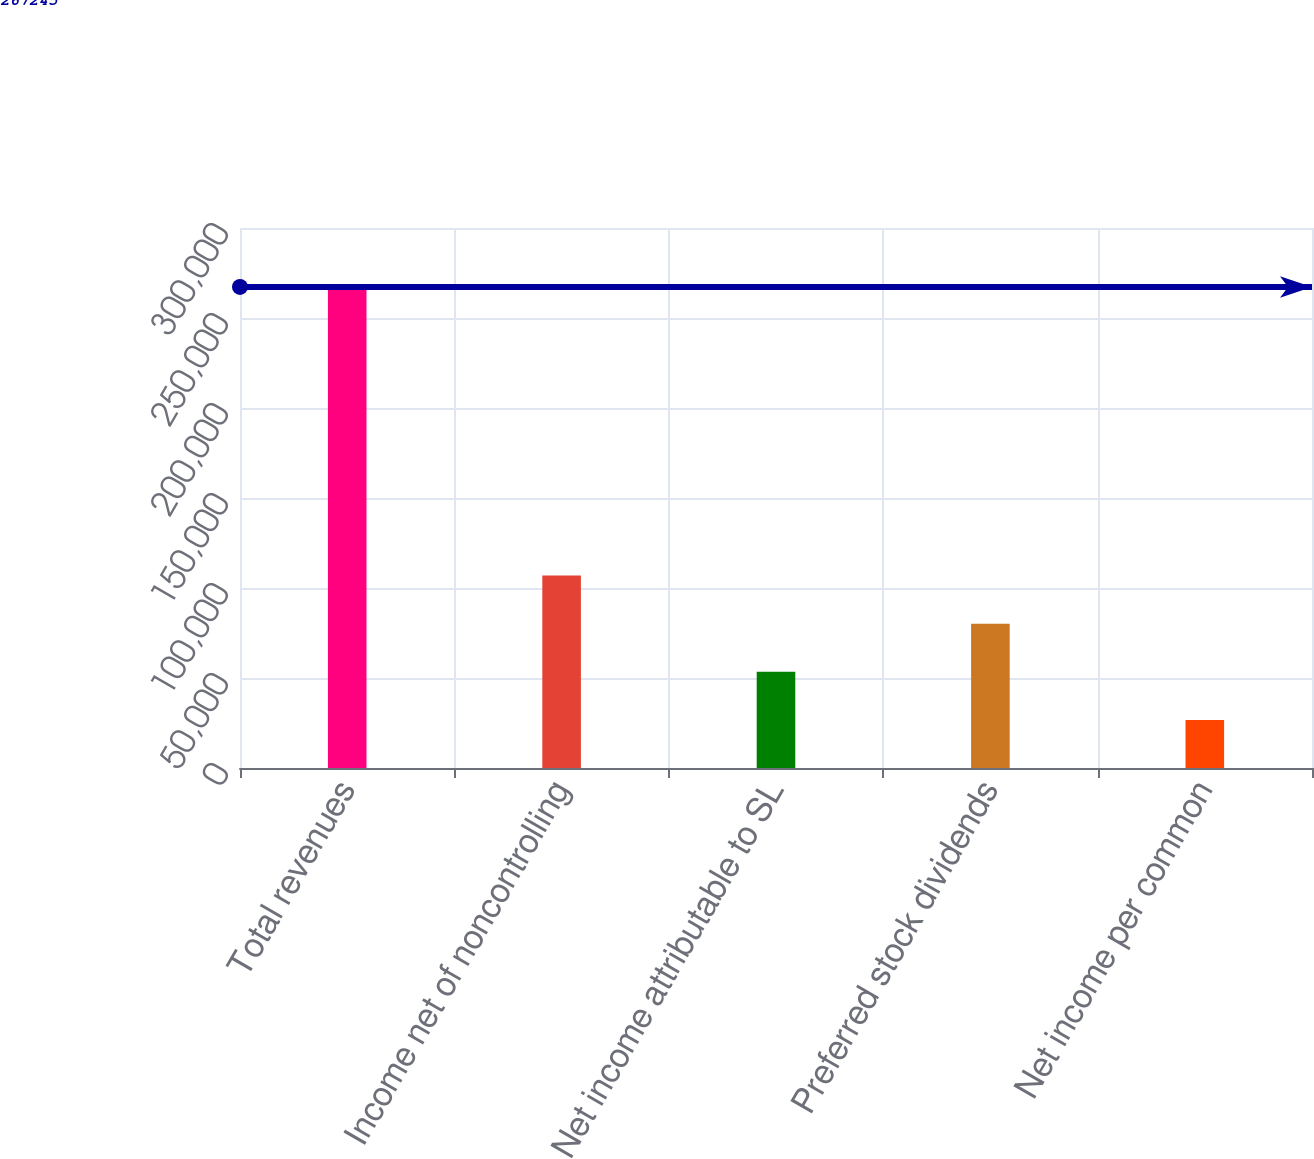<chart> <loc_0><loc_0><loc_500><loc_500><bar_chart><fcel>Total revenues<fcel>Income net of noncontrolling<fcel>Net income attributable to SL<fcel>Preferred stock dividends<fcel>Net income per common<nl><fcel>267245<fcel>106898<fcel>53449.1<fcel>80173.6<fcel>26724.6<nl></chart> 